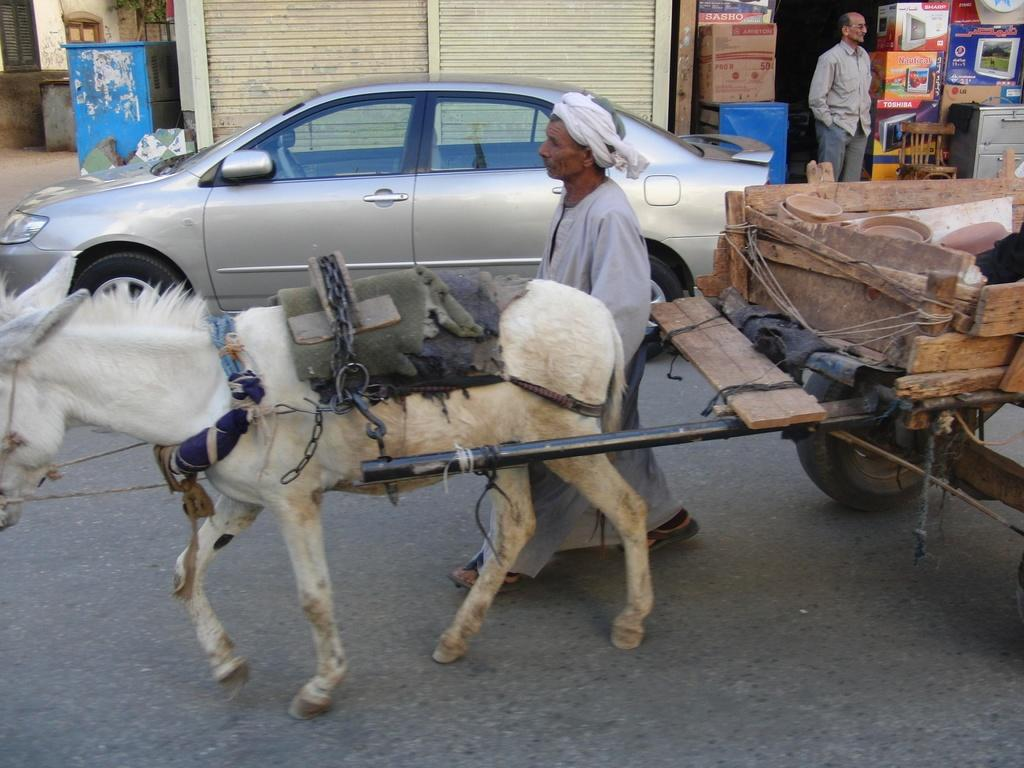What is the main subject of the image? The main subject of the image is a horse with a cart. What other structures or objects can be seen in the image? There is a house, a person, a vehicle, stores, cardboard boxes, a chair, and windows in the image. Can you describe the person in the image? There is a person beside the house in the image. What is the purpose of the cart attached to the horse? The purpose of the cart is not explicitly mentioned in the image, but it could be used for transportation or carrying goods. How many weeks does the person in the image need to fold the cardboard boxes? There is no indication of time or the need to fold cardboard boxes in the image. 